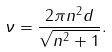<formula> <loc_0><loc_0><loc_500><loc_500>\nu = \frac { 2 \pi n ^ { 2 } d } { \sqrt { n ^ { 2 } + 1 } } .</formula> 